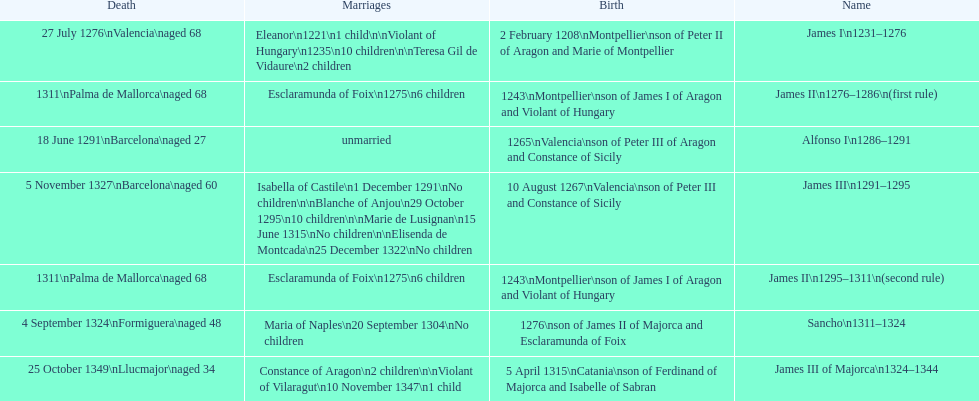James i and james ii both died at what age? 68. 